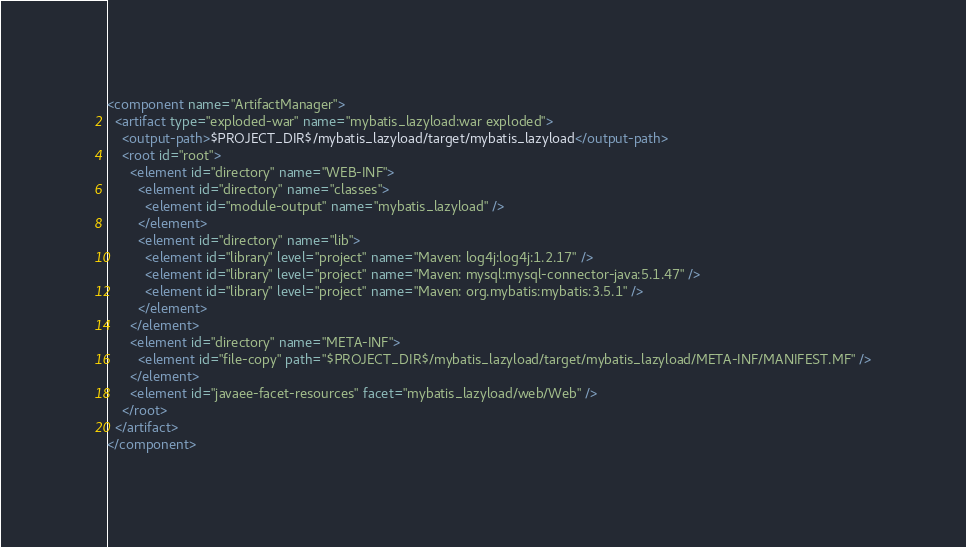Convert code to text. <code><loc_0><loc_0><loc_500><loc_500><_XML_><component name="ArtifactManager">
  <artifact type="exploded-war" name="mybatis_lazyload:war exploded">
    <output-path>$PROJECT_DIR$/mybatis_lazyload/target/mybatis_lazyload</output-path>
    <root id="root">
      <element id="directory" name="WEB-INF">
        <element id="directory" name="classes">
          <element id="module-output" name="mybatis_lazyload" />
        </element>
        <element id="directory" name="lib">
          <element id="library" level="project" name="Maven: log4j:log4j:1.2.17" />
          <element id="library" level="project" name="Maven: mysql:mysql-connector-java:5.1.47" />
          <element id="library" level="project" name="Maven: org.mybatis:mybatis:3.5.1" />
        </element>
      </element>
      <element id="directory" name="META-INF">
        <element id="file-copy" path="$PROJECT_DIR$/mybatis_lazyload/target/mybatis_lazyload/META-INF/MANIFEST.MF" />
      </element>
      <element id="javaee-facet-resources" facet="mybatis_lazyload/web/Web" />
    </root>
  </artifact>
</component></code> 